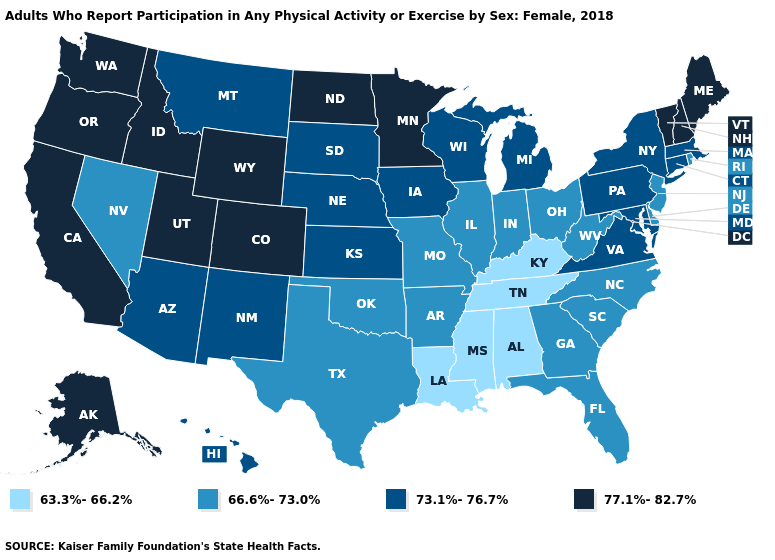What is the highest value in the Northeast ?
Write a very short answer. 77.1%-82.7%. Which states have the highest value in the USA?
Quick response, please. Alaska, California, Colorado, Idaho, Maine, Minnesota, New Hampshire, North Dakota, Oregon, Utah, Vermont, Washington, Wyoming. Does Montana have the highest value in the West?
Concise answer only. No. Which states have the lowest value in the USA?
Keep it brief. Alabama, Kentucky, Louisiana, Mississippi, Tennessee. Among the states that border Indiana , which have the lowest value?
Quick response, please. Kentucky. Does Maine have the lowest value in the Northeast?
Concise answer only. No. Name the states that have a value in the range 63.3%-66.2%?
Write a very short answer. Alabama, Kentucky, Louisiana, Mississippi, Tennessee. What is the value of Alaska?
Keep it brief. 77.1%-82.7%. What is the value of New Hampshire?
Keep it brief. 77.1%-82.7%. How many symbols are there in the legend?
Answer briefly. 4. Which states hav the highest value in the Northeast?
Answer briefly. Maine, New Hampshire, Vermont. Is the legend a continuous bar?
Write a very short answer. No. What is the lowest value in the South?
Write a very short answer. 63.3%-66.2%. What is the value of Maine?
Quick response, please. 77.1%-82.7%. Name the states that have a value in the range 77.1%-82.7%?
Short answer required. Alaska, California, Colorado, Idaho, Maine, Minnesota, New Hampshire, North Dakota, Oregon, Utah, Vermont, Washington, Wyoming. 